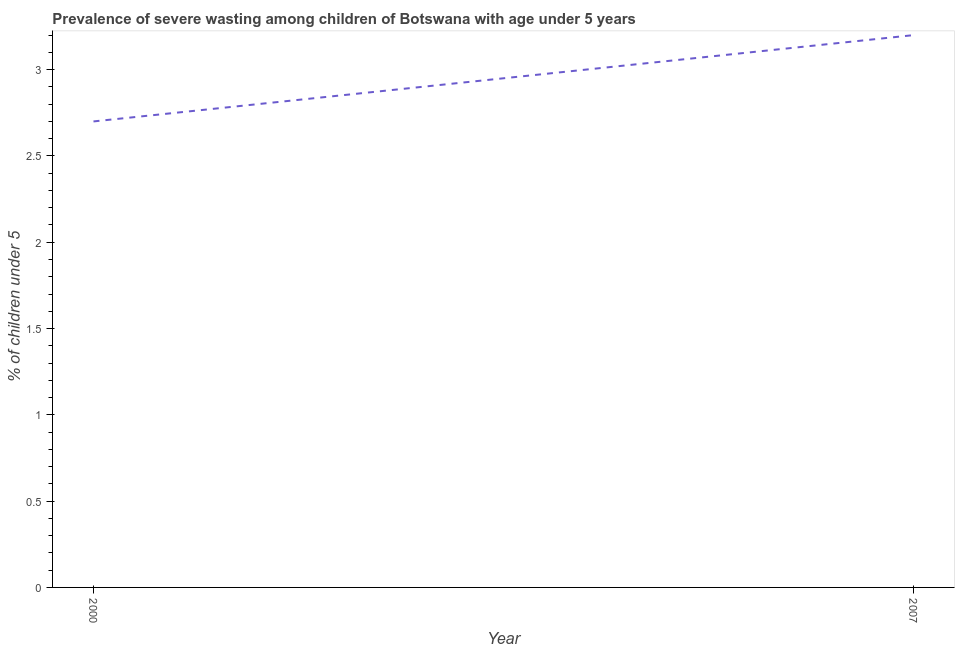What is the prevalence of severe wasting in 2007?
Give a very brief answer. 3.2. Across all years, what is the maximum prevalence of severe wasting?
Offer a terse response. 3.2. Across all years, what is the minimum prevalence of severe wasting?
Keep it short and to the point. 2.7. In which year was the prevalence of severe wasting maximum?
Offer a very short reply. 2007. What is the sum of the prevalence of severe wasting?
Keep it short and to the point. 5.9. What is the average prevalence of severe wasting per year?
Provide a succinct answer. 2.95. What is the median prevalence of severe wasting?
Give a very brief answer. 2.95. In how many years, is the prevalence of severe wasting greater than 2.5 %?
Your response must be concise. 2. What is the ratio of the prevalence of severe wasting in 2000 to that in 2007?
Offer a very short reply. 0.84. Does the prevalence of severe wasting monotonically increase over the years?
Your answer should be compact. Yes. How many lines are there?
Your answer should be compact. 1. How many years are there in the graph?
Keep it short and to the point. 2. Does the graph contain any zero values?
Keep it short and to the point. No. Does the graph contain grids?
Offer a very short reply. No. What is the title of the graph?
Provide a succinct answer. Prevalence of severe wasting among children of Botswana with age under 5 years. What is the label or title of the X-axis?
Provide a short and direct response. Year. What is the label or title of the Y-axis?
Keep it short and to the point.  % of children under 5. What is the  % of children under 5 in 2000?
Give a very brief answer. 2.7. What is the  % of children under 5 in 2007?
Your response must be concise. 3.2. What is the ratio of the  % of children under 5 in 2000 to that in 2007?
Make the answer very short. 0.84. 